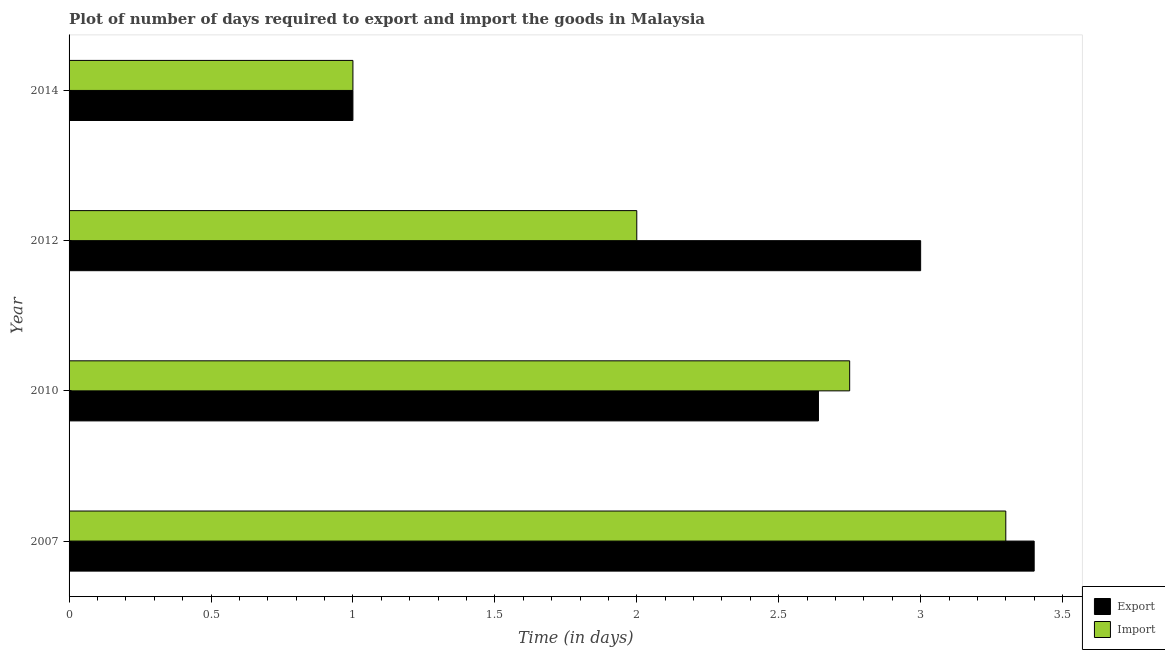How many groups of bars are there?
Ensure brevity in your answer.  4. Are the number of bars per tick equal to the number of legend labels?
Your response must be concise. Yes. Are the number of bars on each tick of the Y-axis equal?
Your answer should be compact. Yes. How many bars are there on the 4th tick from the top?
Offer a very short reply. 2. How many bars are there on the 2nd tick from the bottom?
Keep it short and to the point. 2. In how many cases, is the number of bars for a given year not equal to the number of legend labels?
Keep it short and to the point. 0. Across all years, what is the maximum time required to export?
Offer a terse response. 3.4. Across all years, what is the minimum time required to import?
Your response must be concise. 1. What is the total time required to export in the graph?
Your answer should be compact. 10.04. What is the difference between the time required to export in 2010 and the time required to import in 2014?
Offer a very short reply. 1.64. What is the average time required to import per year?
Provide a short and direct response. 2.26. Is the difference between the time required to import in 2007 and 2012 greater than the difference between the time required to export in 2007 and 2012?
Your answer should be very brief. Yes. What is the difference between the highest and the second highest time required to export?
Give a very brief answer. 0.4. What is the difference between the highest and the lowest time required to export?
Keep it short and to the point. 2.4. Is the sum of the time required to export in 2010 and 2012 greater than the maximum time required to import across all years?
Keep it short and to the point. Yes. What does the 2nd bar from the top in 2014 represents?
Make the answer very short. Export. What does the 1st bar from the bottom in 2014 represents?
Provide a succinct answer. Export. How many years are there in the graph?
Provide a succinct answer. 4. Does the graph contain any zero values?
Keep it short and to the point. No. How many legend labels are there?
Your answer should be very brief. 2. How are the legend labels stacked?
Ensure brevity in your answer.  Vertical. What is the title of the graph?
Make the answer very short. Plot of number of days required to export and import the goods in Malaysia. Does "By country of origin" appear as one of the legend labels in the graph?
Provide a short and direct response. No. What is the label or title of the X-axis?
Your response must be concise. Time (in days). What is the label or title of the Y-axis?
Offer a very short reply. Year. What is the Time (in days) of Export in 2007?
Provide a short and direct response. 3.4. What is the Time (in days) in Export in 2010?
Provide a succinct answer. 2.64. What is the Time (in days) of Import in 2010?
Give a very brief answer. 2.75. What is the Time (in days) of Export in 2012?
Offer a terse response. 3. What is the Time (in days) of Export in 2014?
Provide a succinct answer. 1. What is the Time (in days) of Import in 2014?
Your response must be concise. 1. Across all years, what is the minimum Time (in days) of Import?
Give a very brief answer. 1. What is the total Time (in days) of Export in the graph?
Offer a very short reply. 10.04. What is the total Time (in days) of Import in the graph?
Provide a short and direct response. 9.05. What is the difference between the Time (in days) of Export in 2007 and that in 2010?
Offer a very short reply. 0.76. What is the difference between the Time (in days) of Import in 2007 and that in 2010?
Offer a very short reply. 0.55. What is the difference between the Time (in days) of Import in 2007 and that in 2012?
Provide a short and direct response. 1.3. What is the difference between the Time (in days) in Export in 2007 and that in 2014?
Offer a terse response. 2.4. What is the difference between the Time (in days) of Import in 2007 and that in 2014?
Your answer should be very brief. 2.3. What is the difference between the Time (in days) in Export in 2010 and that in 2012?
Ensure brevity in your answer.  -0.36. What is the difference between the Time (in days) of Export in 2010 and that in 2014?
Offer a very short reply. 1.64. What is the difference between the Time (in days) in Export in 2012 and that in 2014?
Ensure brevity in your answer.  2. What is the difference between the Time (in days) in Import in 2012 and that in 2014?
Provide a succinct answer. 1. What is the difference between the Time (in days) of Export in 2007 and the Time (in days) of Import in 2010?
Your answer should be very brief. 0.65. What is the difference between the Time (in days) of Export in 2007 and the Time (in days) of Import in 2014?
Make the answer very short. 2.4. What is the difference between the Time (in days) of Export in 2010 and the Time (in days) of Import in 2012?
Your response must be concise. 0.64. What is the difference between the Time (in days) in Export in 2010 and the Time (in days) in Import in 2014?
Ensure brevity in your answer.  1.64. What is the average Time (in days) in Export per year?
Offer a very short reply. 2.51. What is the average Time (in days) in Import per year?
Give a very brief answer. 2.26. In the year 2007, what is the difference between the Time (in days) in Export and Time (in days) in Import?
Give a very brief answer. 0.1. In the year 2010, what is the difference between the Time (in days) in Export and Time (in days) in Import?
Your answer should be compact. -0.11. In the year 2014, what is the difference between the Time (in days) of Export and Time (in days) of Import?
Provide a succinct answer. 0. What is the ratio of the Time (in days) of Export in 2007 to that in 2010?
Your answer should be very brief. 1.29. What is the ratio of the Time (in days) of Export in 2007 to that in 2012?
Provide a succinct answer. 1.13. What is the ratio of the Time (in days) of Import in 2007 to that in 2012?
Provide a short and direct response. 1.65. What is the ratio of the Time (in days) of Export in 2007 to that in 2014?
Make the answer very short. 3.4. What is the ratio of the Time (in days) in Import in 2007 to that in 2014?
Keep it short and to the point. 3.3. What is the ratio of the Time (in days) of Import in 2010 to that in 2012?
Give a very brief answer. 1.38. What is the ratio of the Time (in days) in Export in 2010 to that in 2014?
Give a very brief answer. 2.64. What is the ratio of the Time (in days) of Import in 2010 to that in 2014?
Offer a very short reply. 2.75. What is the difference between the highest and the second highest Time (in days) of Import?
Your answer should be very brief. 0.55. What is the difference between the highest and the lowest Time (in days) in Import?
Your response must be concise. 2.3. 